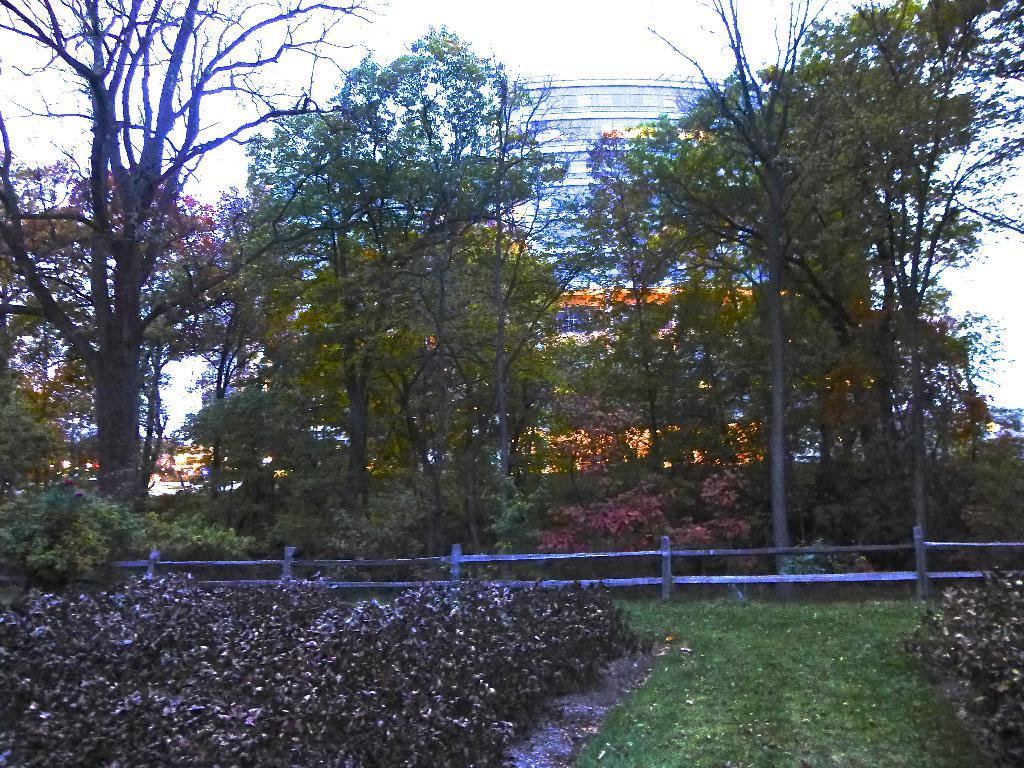What type of vegetation can be seen in the image? There are trees in the image. What type of barrier is present in the image? There is a fence in the image. What other objects can be seen in the image besides trees and the fence? There are other objects in the image. What can be seen in the background of the image? The sky is visible in the background of the image. What type of vegetation is present at the bottom of the image? There are plants at the bottom of the image. What type of ground cover is present at the bottom of the image? There is grass at the bottom of the image. How many trucks are parked near the fence in the image? There are no trucks present in the image. Can you tell me how many chickens are roaming around in the grass at the bottom of the image? There are no chickens present in the image. 